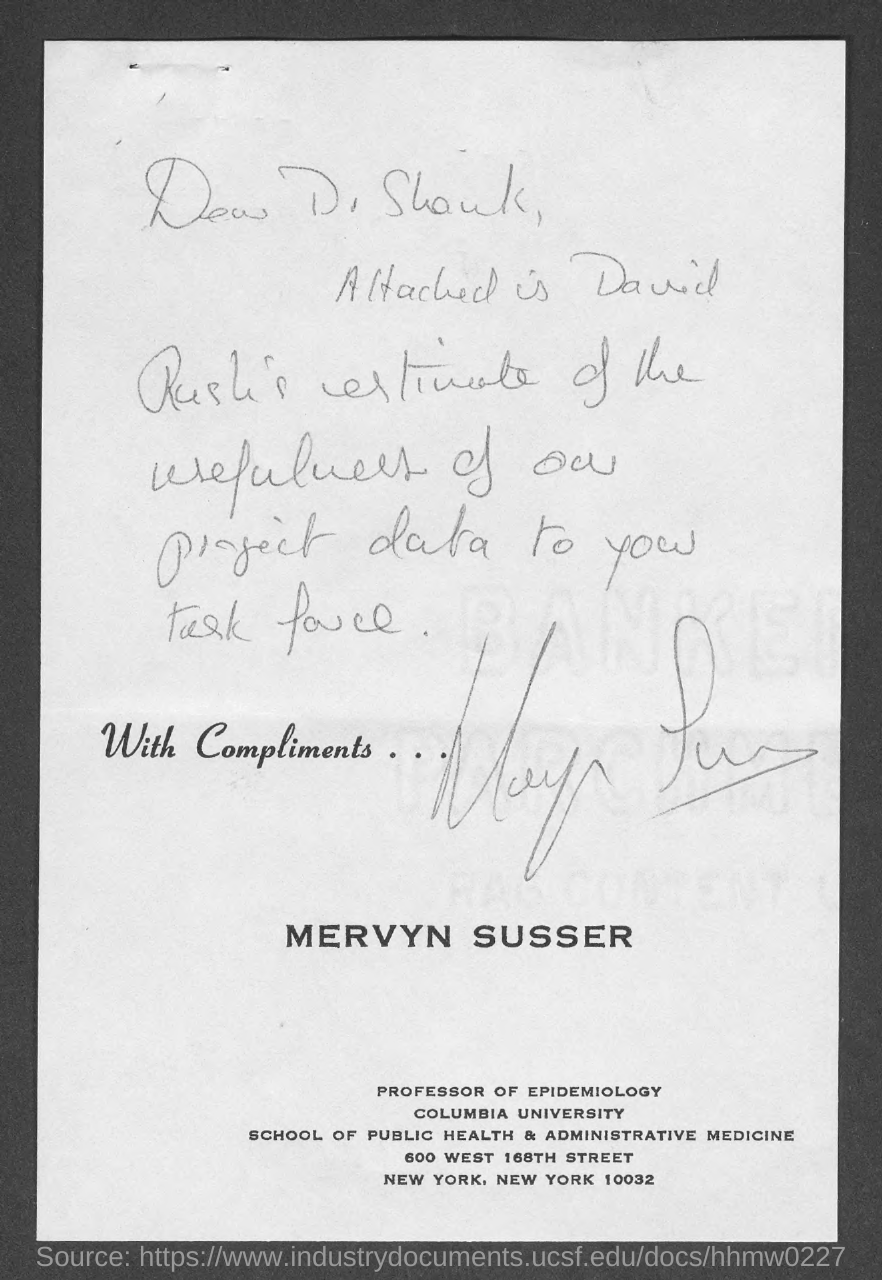Who has signed the document?
Your answer should be very brief. Mervyn susser. What is the designation of MERVYN SUSSER?
Provide a succinct answer. Professor of epidemiology. In which University, Mervyn Susser works?
Provide a succinct answer. Columbia university. To whom, the document is addressed?
Provide a succinct answer. Dr Shank. 